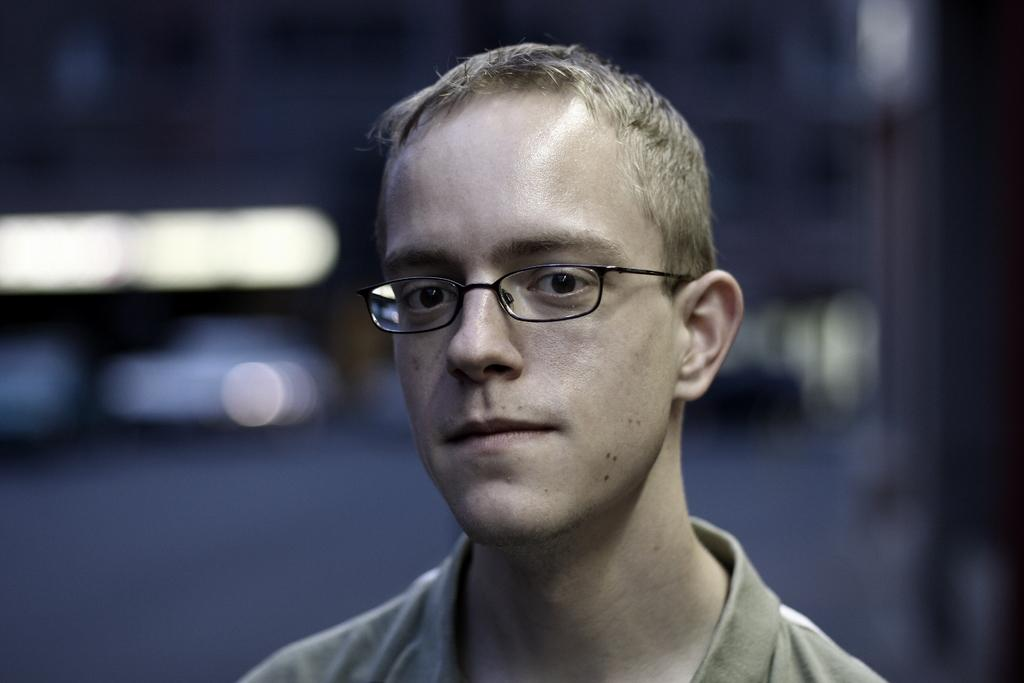What is the main subject of the image? The main subject of the image is a man. What is the man doing in the image? The man is looking to one side in the image. What type of clothing is the man wearing? The man is wearing a t-shirt in the image. Are there any accessories visible on the man? Yes, the man is wearing spectacles in the image. What type of food is the man feeding to his pets in the image? There is no food or pets present in the image; it only features a man looking to one side while wearing a t-shirt and spectacles. 